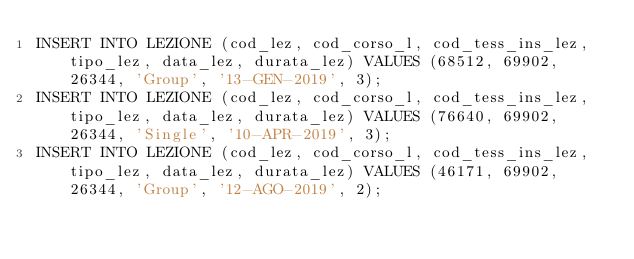<code> <loc_0><loc_0><loc_500><loc_500><_SQL_>INSERT INTO LEZIONE (cod_lez, cod_corso_l, cod_tess_ins_lez, tipo_lez, data_lez, durata_lez) VALUES (68512, 69902, 26344, 'Group', '13-GEN-2019', 3);
INSERT INTO LEZIONE (cod_lez, cod_corso_l, cod_tess_ins_lez, tipo_lez, data_lez, durata_lez) VALUES (76640, 69902, 26344, 'Single', '10-APR-2019', 3);
INSERT INTO LEZIONE (cod_lez, cod_corso_l, cod_tess_ins_lez, tipo_lez, data_lez, durata_lez) VALUES (46171, 69902, 26344, 'Group', '12-AGO-2019', 2);</code> 